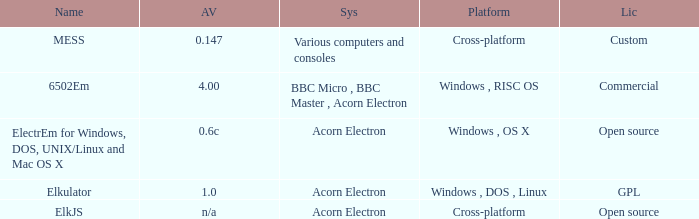What is the title of the platform utilized for multiple computers and gaming consoles? Cross-platform. Can you parse all the data within this table? {'header': ['Name', 'AV', 'Sys', 'Platform', 'Lic'], 'rows': [['MESS', '0.147', 'Various computers and consoles', 'Cross-platform', 'Custom'], ['6502Em', '4.00', 'BBC Micro , BBC Master , Acorn Electron', 'Windows , RISC OS', 'Commercial'], ['ElectrEm for Windows, DOS, UNIX/Linux and Mac OS X', '0.6c', 'Acorn Electron', 'Windows , OS X', 'Open source'], ['Elkulator', '1.0', 'Acorn Electron', 'Windows , DOS , Linux', 'GPL'], ['ElkJS', 'n/a', 'Acorn Electron', 'Cross-platform', 'Open source']]} 